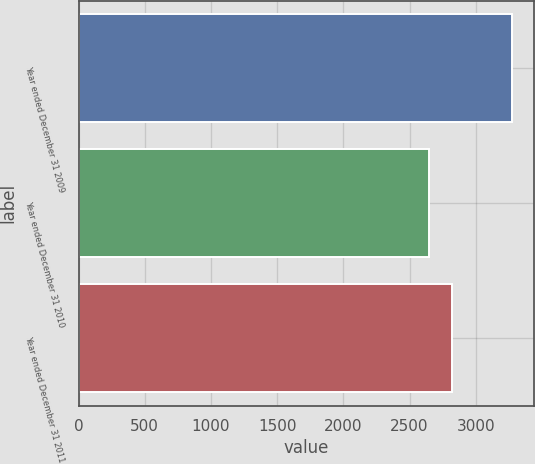Convert chart. <chart><loc_0><loc_0><loc_500><loc_500><bar_chart><fcel>Year ended December 31 2009<fcel>Year ended December 31 2010<fcel>Year ended December 31 2011<nl><fcel>3276<fcel>2648<fcel>2824<nl></chart> 